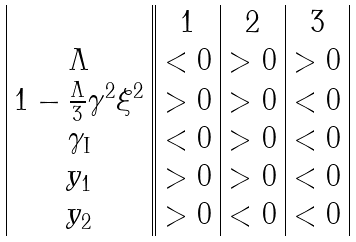<formula> <loc_0><loc_0><loc_500><loc_500>\begin{array} { | c | | c | c | c | } & 1 & 2 & 3 \\ \Lambda & < 0 & > 0 & > 0 \\ 1 - \frac { \Lambda } { 3 } \gamma ^ { 2 } \xi ^ { 2 } & > 0 & > 0 & < 0 \\ \gamma _ { \text {I} } & < 0 & > 0 & < 0 \\ y _ { 1 } & > 0 & > 0 & < 0 \\ y _ { 2 } & > 0 & < 0 & < 0 \\ \end{array}</formula> 